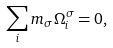Convert formula to latex. <formula><loc_0><loc_0><loc_500><loc_500>\sum _ { i } m _ { \sigma } \Omega ^ { \sigma } _ { i } = 0 ,</formula> 